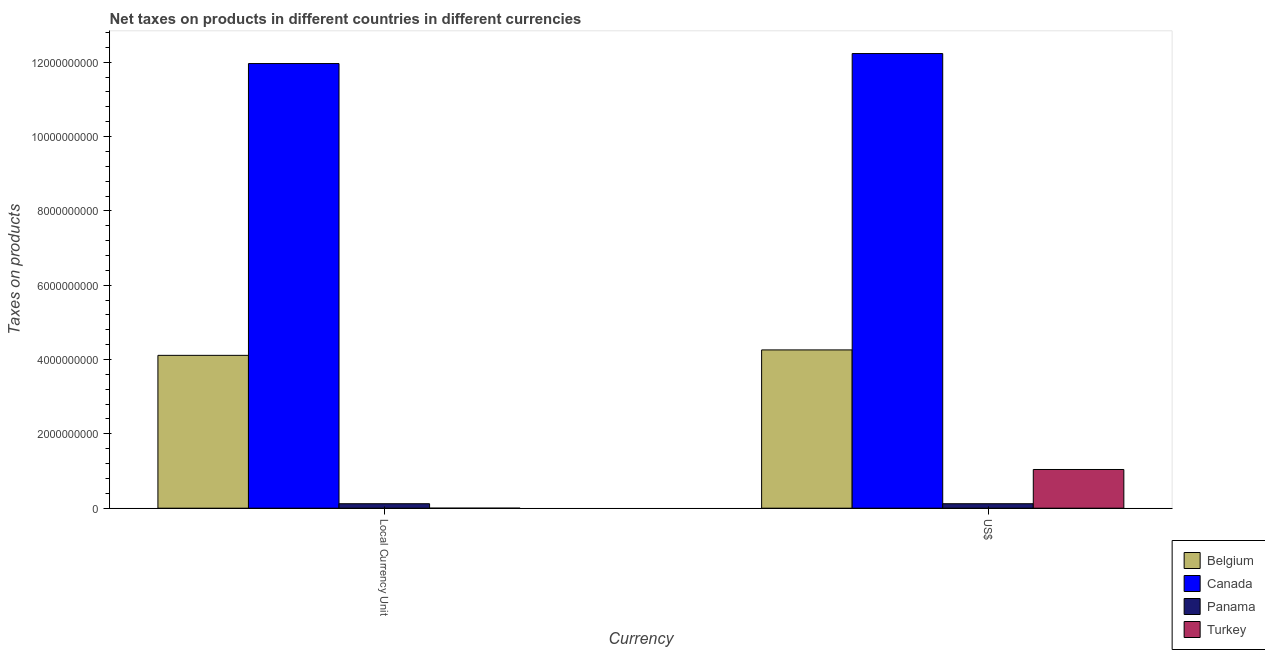Are the number of bars per tick equal to the number of legend labels?
Provide a short and direct response. Yes. How many bars are there on the 1st tick from the right?
Ensure brevity in your answer.  4. What is the label of the 2nd group of bars from the left?
Offer a very short reply. US$. What is the net taxes in constant 2005 us$ in Panama?
Keep it short and to the point. 1.20e+08. Across all countries, what is the maximum net taxes in us$?
Your answer should be compact. 1.22e+1. Across all countries, what is the minimum net taxes in constant 2005 us$?
Keep it short and to the point. 1.45e+04. In which country was the net taxes in us$ minimum?
Provide a succinct answer. Panama. What is the total net taxes in us$ in the graph?
Offer a very short reply. 1.77e+1. What is the difference between the net taxes in constant 2005 us$ in Belgium and that in Turkey?
Make the answer very short. 4.11e+09. What is the difference between the net taxes in constant 2005 us$ in Turkey and the net taxes in us$ in Panama?
Your answer should be compact. -1.20e+08. What is the average net taxes in us$ per country?
Provide a succinct answer. 4.41e+09. What is the difference between the net taxes in us$ and net taxes in constant 2005 us$ in Belgium?
Offer a very short reply. 1.47e+08. In how many countries, is the net taxes in us$ greater than 10000000000 units?
Your answer should be compact. 1. What is the ratio of the net taxes in us$ in Turkey to that in Canada?
Give a very brief answer. 0.09. What does the 1st bar from the left in Local Currency Unit represents?
Your answer should be very brief. Belgium. Are all the bars in the graph horizontal?
Offer a terse response. No. How many countries are there in the graph?
Your answer should be compact. 4. What is the difference between two consecutive major ticks on the Y-axis?
Provide a short and direct response. 2.00e+09. Are the values on the major ticks of Y-axis written in scientific E-notation?
Your answer should be very brief. No. How are the legend labels stacked?
Ensure brevity in your answer.  Vertical. What is the title of the graph?
Make the answer very short. Net taxes on products in different countries in different currencies. Does "Cambodia" appear as one of the legend labels in the graph?
Ensure brevity in your answer.  No. What is the label or title of the X-axis?
Give a very brief answer. Currency. What is the label or title of the Y-axis?
Provide a short and direct response. Taxes on products. What is the Taxes on products of Belgium in Local Currency Unit?
Offer a very short reply. 4.11e+09. What is the Taxes on products of Canada in Local Currency Unit?
Provide a short and direct response. 1.20e+1. What is the Taxes on products in Panama in Local Currency Unit?
Provide a short and direct response. 1.20e+08. What is the Taxes on products of Turkey in Local Currency Unit?
Provide a short and direct response. 1.45e+04. What is the Taxes on products of Belgium in US$?
Your answer should be very brief. 4.26e+09. What is the Taxes on products of Canada in US$?
Offer a very short reply. 1.22e+1. What is the Taxes on products of Panama in US$?
Your answer should be compact. 1.20e+08. What is the Taxes on products in Turkey in US$?
Provide a short and direct response. 1.04e+09. Across all Currency, what is the maximum Taxes on products in Belgium?
Ensure brevity in your answer.  4.26e+09. Across all Currency, what is the maximum Taxes on products in Canada?
Your response must be concise. 1.22e+1. Across all Currency, what is the maximum Taxes on products of Panama?
Provide a short and direct response. 1.20e+08. Across all Currency, what is the maximum Taxes on products in Turkey?
Offer a terse response. 1.04e+09. Across all Currency, what is the minimum Taxes on products in Belgium?
Your answer should be very brief. 4.11e+09. Across all Currency, what is the minimum Taxes on products in Canada?
Your answer should be compact. 1.20e+1. Across all Currency, what is the minimum Taxes on products of Panama?
Provide a succinct answer. 1.20e+08. Across all Currency, what is the minimum Taxes on products of Turkey?
Make the answer very short. 1.45e+04. What is the total Taxes on products in Belgium in the graph?
Your answer should be very brief. 8.37e+09. What is the total Taxes on products of Canada in the graph?
Your answer should be very brief. 2.42e+1. What is the total Taxes on products in Panama in the graph?
Provide a succinct answer. 2.40e+08. What is the total Taxes on products of Turkey in the graph?
Make the answer very short. 1.04e+09. What is the difference between the Taxes on products of Belgium in Local Currency Unit and that in US$?
Make the answer very short. -1.47e+08. What is the difference between the Taxes on products of Canada in Local Currency Unit and that in US$?
Offer a very short reply. -2.69e+08. What is the difference between the Taxes on products in Panama in Local Currency Unit and that in US$?
Your answer should be compact. 0. What is the difference between the Taxes on products in Turkey in Local Currency Unit and that in US$?
Ensure brevity in your answer.  -1.04e+09. What is the difference between the Taxes on products of Belgium in Local Currency Unit and the Taxes on products of Canada in US$?
Provide a short and direct response. -8.12e+09. What is the difference between the Taxes on products of Belgium in Local Currency Unit and the Taxes on products of Panama in US$?
Provide a succinct answer. 3.99e+09. What is the difference between the Taxes on products in Belgium in Local Currency Unit and the Taxes on products in Turkey in US$?
Offer a terse response. 3.07e+09. What is the difference between the Taxes on products in Canada in Local Currency Unit and the Taxes on products in Panama in US$?
Give a very brief answer. 1.18e+1. What is the difference between the Taxes on products of Canada in Local Currency Unit and the Taxes on products of Turkey in US$?
Your answer should be very brief. 1.09e+1. What is the difference between the Taxes on products of Panama in Local Currency Unit and the Taxes on products of Turkey in US$?
Provide a succinct answer. -9.21e+08. What is the average Taxes on products in Belgium per Currency?
Your answer should be very brief. 4.19e+09. What is the average Taxes on products in Canada per Currency?
Make the answer very short. 1.21e+1. What is the average Taxes on products in Panama per Currency?
Your answer should be compact. 1.20e+08. What is the average Taxes on products of Turkey per Currency?
Keep it short and to the point. 5.21e+08. What is the difference between the Taxes on products in Belgium and Taxes on products in Canada in Local Currency Unit?
Provide a succinct answer. -7.85e+09. What is the difference between the Taxes on products in Belgium and Taxes on products in Panama in Local Currency Unit?
Give a very brief answer. 3.99e+09. What is the difference between the Taxes on products in Belgium and Taxes on products in Turkey in Local Currency Unit?
Offer a very short reply. 4.11e+09. What is the difference between the Taxes on products in Canada and Taxes on products in Panama in Local Currency Unit?
Your answer should be compact. 1.18e+1. What is the difference between the Taxes on products in Canada and Taxes on products in Turkey in Local Currency Unit?
Your answer should be very brief. 1.20e+1. What is the difference between the Taxes on products of Panama and Taxes on products of Turkey in Local Currency Unit?
Your response must be concise. 1.20e+08. What is the difference between the Taxes on products in Belgium and Taxes on products in Canada in US$?
Your response must be concise. -7.97e+09. What is the difference between the Taxes on products in Belgium and Taxes on products in Panama in US$?
Provide a succinct answer. 4.14e+09. What is the difference between the Taxes on products of Belgium and Taxes on products of Turkey in US$?
Your response must be concise. 3.22e+09. What is the difference between the Taxes on products in Canada and Taxes on products in Panama in US$?
Offer a terse response. 1.21e+1. What is the difference between the Taxes on products of Canada and Taxes on products of Turkey in US$?
Offer a very short reply. 1.12e+1. What is the difference between the Taxes on products in Panama and Taxes on products in Turkey in US$?
Your answer should be compact. -9.21e+08. What is the ratio of the Taxes on products of Belgium in Local Currency Unit to that in US$?
Make the answer very short. 0.97. What is the ratio of the Taxes on products of Canada in Local Currency Unit to that in US$?
Provide a succinct answer. 0.98. What is the difference between the highest and the second highest Taxes on products of Belgium?
Give a very brief answer. 1.47e+08. What is the difference between the highest and the second highest Taxes on products of Canada?
Your answer should be compact. 2.69e+08. What is the difference between the highest and the second highest Taxes on products in Panama?
Offer a very short reply. 0. What is the difference between the highest and the second highest Taxes on products in Turkey?
Provide a short and direct response. 1.04e+09. What is the difference between the highest and the lowest Taxes on products of Belgium?
Your answer should be very brief. 1.47e+08. What is the difference between the highest and the lowest Taxes on products in Canada?
Ensure brevity in your answer.  2.69e+08. What is the difference between the highest and the lowest Taxes on products of Panama?
Keep it short and to the point. 0. What is the difference between the highest and the lowest Taxes on products in Turkey?
Your answer should be compact. 1.04e+09. 